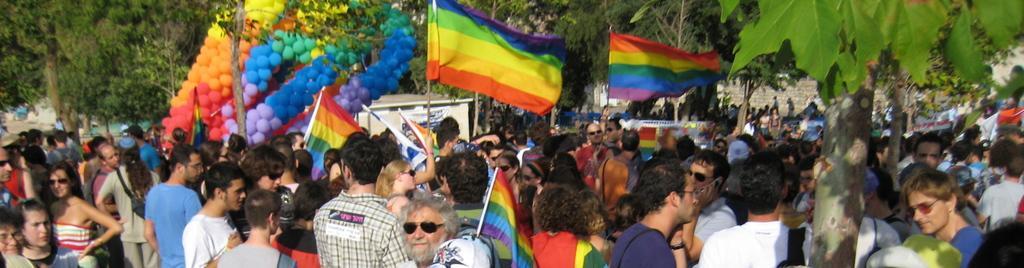Describe this image in one or two sentences. In the picture we can see group of people standing, most of them are holding flags in their hands and in the background of the picture there are some trees, balloons. 